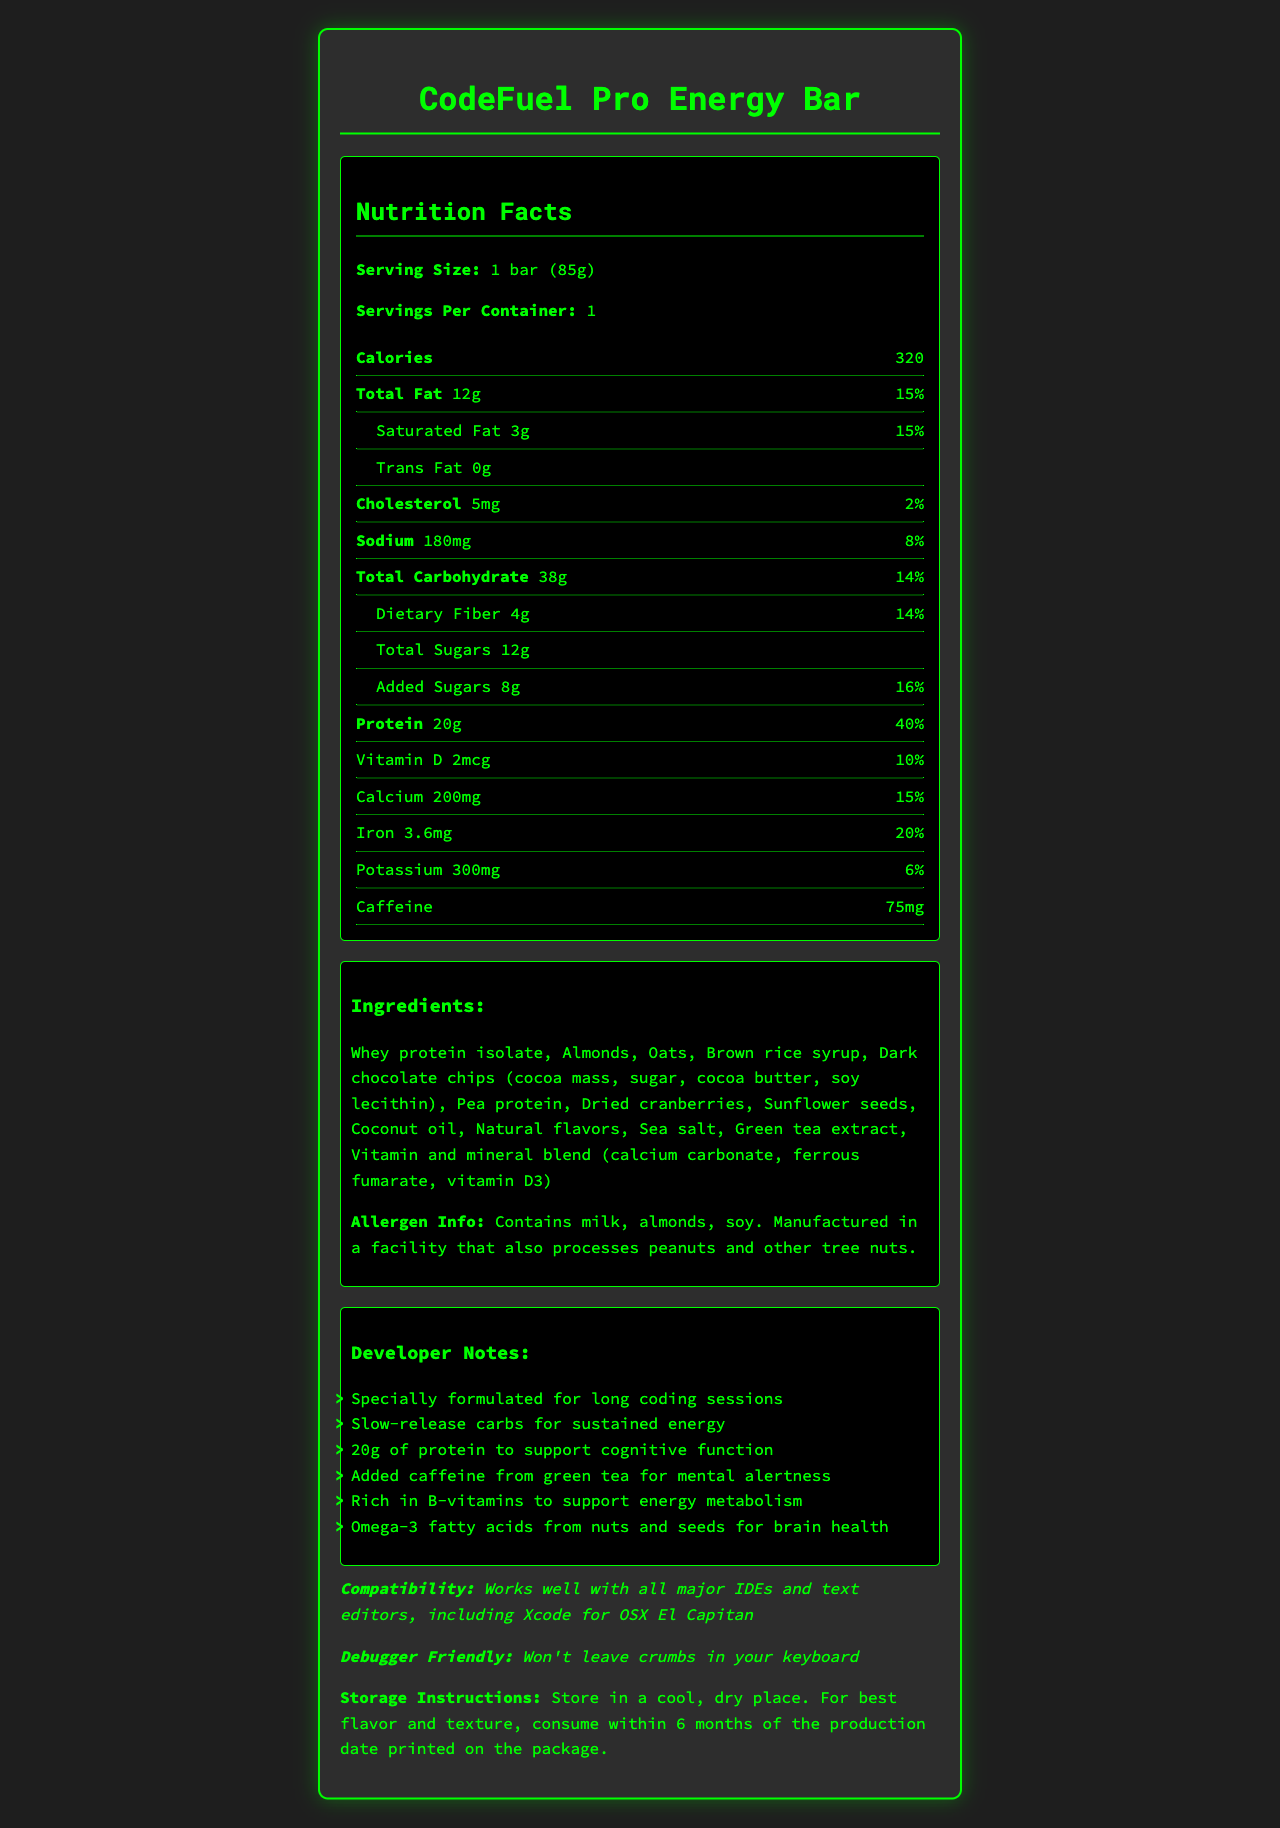what is the serving size of the CodeFuel Pro Energy Bar? The serving size is mentioned in the nutrition facts section as "Serving Size: 1 bar (85g)".
Answer: 1 bar (85g) how many calories are in one serving? The number of calories is listed next to "Calories" in the nutrition facts section.
Answer: 320 what is the total fat content and its daily value? The total fat amount and its daily value are listed in the nutrition facts section as "Total Fat 12g 15%".
Answer: 12g, 15% how much protein does the bar contain? The protein amount is stated in the nutrition facts section as "Protein 20g".
Answer: 20g what allergens are present in the CodeFuel Pro Energy Bar? The allergen information states that the bar contains milk, almonds, and soy.
Answer: Milk, almonds, soy how much caffeine does the CodeFuel Pro Energy Bar have? Caffeine content is listed in the nutrition facts section as 75mg.
Answer: 75mg what is the amount of dietary fiber in the bar? A. 2g B. 4g C. 6g D. 8g The dietary fiber amount is indicated in the nutrition facts section as "Dietary Fiber 4g".
Answer: B how much added sugar does the bar contain? A. 4g B. 6g C. 8g D. 10g The amount of added sugars is listed in the nutrition facts section as "Added Sugars 8g".
Answer: C is the CodeFuel Pro Energy Bar suitable for people avoiding peanuts? The allergen info states it is manufactured in a facility that also processes peanuts.
Answer: No does the CodeFuel Pro Energy Bar contain any trans fat? The nutrition facts section lists "Trans Fat 0g".
Answer: No which vitamin is present in the highest amount in the CodeFuel Pro Energy Bar? The nutrition facts section indicates that iron is present at 20% daily value, higher than other vitamins and minerals listed.
Answer: Iron how should you store the CodeFuel Pro Energy Bar for optimal flavor and texture? The storage instructions mention storing in a cool and dry place.
Answer: Store in a cool, dry place. can the exact production date of the bar be determined from the document? The document states "consume within 6 months of the production date printed on the package," but the actual production date is not provided in the visual information.
Answer: No summarize the main features and benefits of the CodeFuel Pro Energy Bar. The document details various features and benefits including nutritional content, protein for cognitive function, caffeine for alertness, important vitamins, minerals, and storage instructions, making it ideal for long coding sessions.
Answer: The CodeFuel Pro Energy Bar provides 320 calories per serving with 20g of protein designed to fuel long coding sessions. It contains slow-release carbs, added caffeine for mental alertness, and is rich in B-vitamins. It includes essential nutrients like iron, calcium, and omega-3 fatty acids. It is allergen-friendly for those avoiding milk and certain nuts but can come into contact with peanuts. Store in a cool, dry place for best results. 